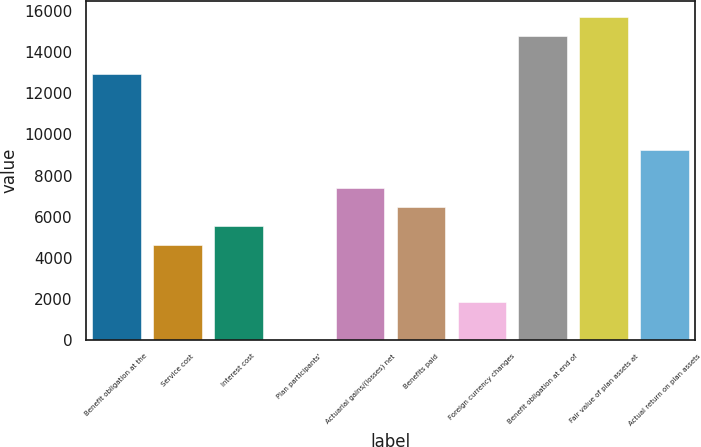Convert chart. <chart><loc_0><loc_0><loc_500><loc_500><bar_chart><fcel>Benefit obligation at the<fcel>Service cost<fcel>Interest cost<fcel>Plan participants'<fcel>Actuarial gains/(losses) net<fcel>Benefits paid<fcel>Foreign currency changes<fcel>Benefit obligation at end of<fcel>Fair value of plan assets at<fcel>Actual return on plan assets<nl><fcel>12944<fcel>4623.5<fcel>5548<fcel>1<fcel>7397<fcel>6472.5<fcel>1850<fcel>14793<fcel>15717.5<fcel>9246<nl></chart> 